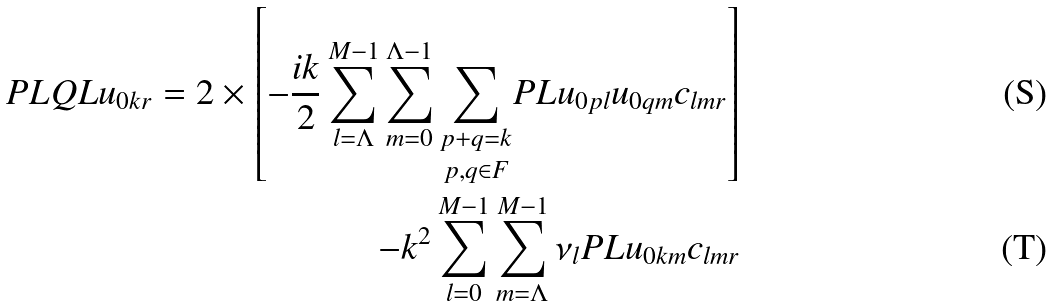<formula> <loc_0><loc_0><loc_500><loc_500>P L Q L u _ { 0 k r } = 2 \times \left [ - \frac { i k } { 2 } \sum _ { l = \Lambda } ^ { M - 1 } \sum _ { m = 0 } ^ { \Lambda - 1 } \underset { p , q \in F } { \underset { p + q = k } { \sum } } P L u _ { 0 p l } u _ { 0 q m } c _ { l m r } \right ] \\ - k ^ { 2 } \sum _ { l = 0 } ^ { M - 1 } \sum _ { m = \Lambda } ^ { M - 1 } \nu _ { l } P L u _ { 0 k m } c _ { l m r }</formula> 